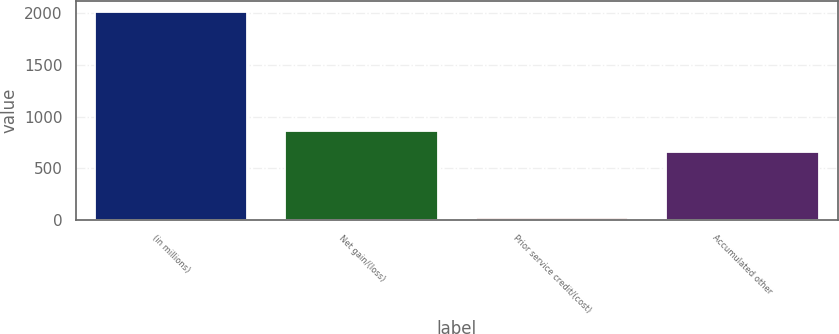<chart> <loc_0><loc_0><loc_500><loc_500><bar_chart><fcel>(in millions)<fcel>Net gain/(loss)<fcel>Prior service credit/(cost)<fcel>Accumulated other<nl><fcel>2012<fcel>857.4<fcel>18<fcel>658<nl></chart> 